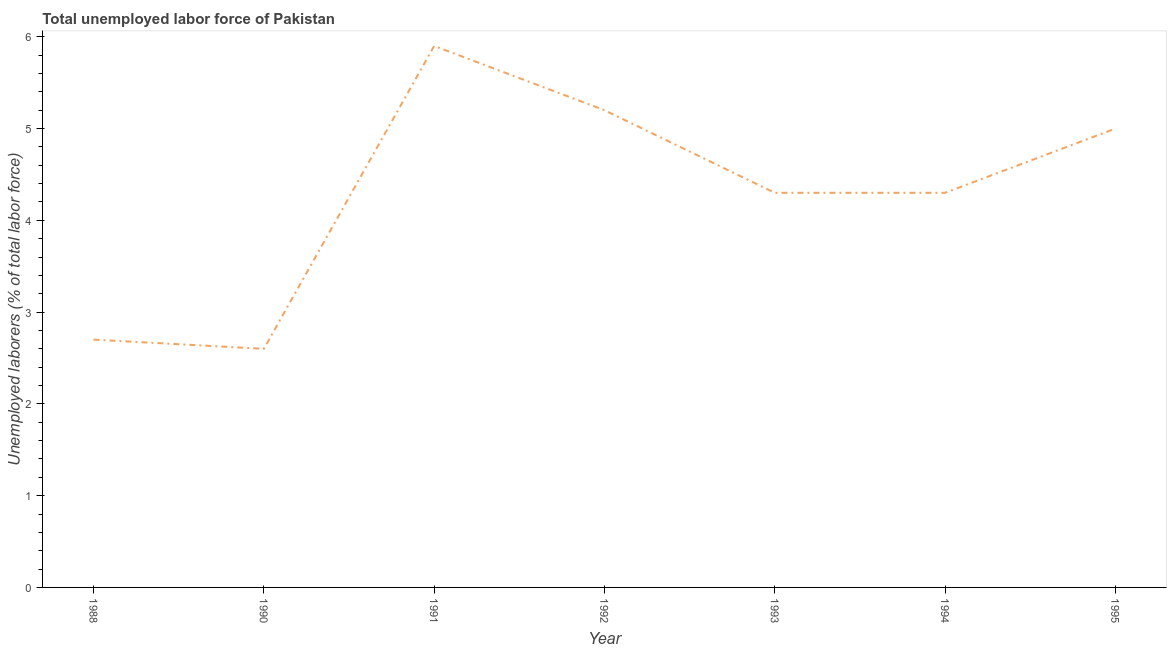What is the total unemployed labour force in 1992?
Give a very brief answer. 5.2. Across all years, what is the maximum total unemployed labour force?
Your answer should be very brief. 5.9. Across all years, what is the minimum total unemployed labour force?
Your response must be concise. 2.6. In which year was the total unemployed labour force maximum?
Your response must be concise. 1991. What is the sum of the total unemployed labour force?
Provide a short and direct response. 30. What is the difference between the total unemployed labour force in 1993 and 1995?
Provide a short and direct response. -0.7. What is the average total unemployed labour force per year?
Offer a terse response. 4.29. What is the median total unemployed labour force?
Ensure brevity in your answer.  4.3. Do a majority of the years between 1988 and 1991 (inclusive) have total unemployed labour force greater than 2.8 %?
Ensure brevity in your answer.  No. What is the ratio of the total unemployed labour force in 1993 to that in 1995?
Give a very brief answer. 0.86. Is the total unemployed labour force in 1988 less than that in 1993?
Offer a terse response. Yes. What is the difference between the highest and the second highest total unemployed labour force?
Your answer should be compact. 0.7. Is the sum of the total unemployed labour force in 1993 and 1994 greater than the maximum total unemployed labour force across all years?
Keep it short and to the point. Yes. What is the difference between the highest and the lowest total unemployed labour force?
Your response must be concise. 3.3. Does the total unemployed labour force monotonically increase over the years?
Give a very brief answer. No. How many years are there in the graph?
Make the answer very short. 7. Are the values on the major ticks of Y-axis written in scientific E-notation?
Keep it short and to the point. No. Does the graph contain grids?
Provide a short and direct response. No. What is the title of the graph?
Offer a very short reply. Total unemployed labor force of Pakistan. What is the label or title of the Y-axis?
Your answer should be compact. Unemployed laborers (% of total labor force). What is the Unemployed laborers (% of total labor force) in 1988?
Your answer should be very brief. 2.7. What is the Unemployed laborers (% of total labor force) of 1990?
Keep it short and to the point. 2.6. What is the Unemployed laborers (% of total labor force) in 1991?
Your answer should be compact. 5.9. What is the Unemployed laborers (% of total labor force) in 1992?
Provide a succinct answer. 5.2. What is the Unemployed laborers (% of total labor force) in 1993?
Offer a very short reply. 4.3. What is the Unemployed laborers (% of total labor force) in 1994?
Your answer should be compact. 4.3. What is the difference between the Unemployed laborers (% of total labor force) in 1988 and 1990?
Ensure brevity in your answer.  0.1. What is the difference between the Unemployed laborers (% of total labor force) in 1988 and 1991?
Provide a short and direct response. -3.2. What is the difference between the Unemployed laborers (% of total labor force) in 1988 and 1993?
Your answer should be very brief. -1.6. What is the difference between the Unemployed laborers (% of total labor force) in 1988 and 1994?
Give a very brief answer. -1.6. What is the difference between the Unemployed laborers (% of total labor force) in 1988 and 1995?
Make the answer very short. -2.3. What is the difference between the Unemployed laborers (% of total labor force) in 1990 and 1991?
Provide a succinct answer. -3.3. What is the difference between the Unemployed laborers (% of total labor force) in 1990 and 1993?
Your response must be concise. -1.7. What is the difference between the Unemployed laborers (% of total labor force) in 1990 and 1995?
Provide a short and direct response. -2.4. What is the difference between the Unemployed laborers (% of total labor force) in 1991 and 1992?
Provide a short and direct response. 0.7. What is the difference between the Unemployed laborers (% of total labor force) in 1992 and 1993?
Offer a terse response. 0.9. What is the difference between the Unemployed laborers (% of total labor force) in 1992 and 1994?
Your answer should be very brief. 0.9. What is the difference between the Unemployed laborers (% of total labor force) in 1992 and 1995?
Your answer should be very brief. 0.2. What is the difference between the Unemployed laborers (% of total labor force) in 1994 and 1995?
Your response must be concise. -0.7. What is the ratio of the Unemployed laborers (% of total labor force) in 1988 to that in 1990?
Offer a very short reply. 1.04. What is the ratio of the Unemployed laborers (% of total labor force) in 1988 to that in 1991?
Ensure brevity in your answer.  0.46. What is the ratio of the Unemployed laborers (% of total labor force) in 1988 to that in 1992?
Give a very brief answer. 0.52. What is the ratio of the Unemployed laborers (% of total labor force) in 1988 to that in 1993?
Make the answer very short. 0.63. What is the ratio of the Unemployed laborers (% of total labor force) in 1988 to that in 1994?
Give a very brief answer. 0.63. What is the ratio of the Unemployed laborers (% of total labor force) in 1988 to that in 1995?
Provide a succinct answer. 0.54. What is the ratio of the Unemployed laborers (% of total labor force) in 1990 to that in 1991?
Offer a terse response. 0.44. What is the ratio of the Unemployed laborers (% of total labor force) in 1990 to that in 1992?
Your response must be concise. 0.5. What is the ratio of the Unemployed laborers (% of total labor force) in 1990 to that in 1993?
Give a very brief answer. 0.6. What is the ratio of the Unemployed laborers (% of total labor force) in 1990 to that in 1994?
Make the answer very short. 0.6. What is the ratio of the Unemployed laborers (% of total labor force) in 1990 to that in 1995?
Your answer should be compact. 0.52. What is the ratio of the Unemployed laborers (% of total labor force) in 1991 to that in 1992?
Provide a short and direct response. 1.14. What is the ratio of the Unemployed laborers (% of total labor force) in 1991 to that in 1993?
Your answer should be very brief. 1.37. What is the ratio of the Unemployed laborers (% of total labor force) in 1991 to that in 1994?
Offer a very short reply. 1.37. What is the ratio of the Unemployed laborers (% of total labor force) in 1991 to that in 1995?
Make the answer very short. 1.18. What is the ratio of the Unemployed laborers (% of total labor force) in 1992 to that in 1993?
Give a very brief answer. 1.21. What is the ratio of the Unemployed laborers (% of total labor force) in 1992 to that in 1994?
Your answer should be very brief. 1.21. What is the ratio of the Unemployed laborers (% of total labor force) in 1993 to that in 1995?
Offer a terse response. 0.86. What is the ratio of the Unemployed laborers (% of total labor force) in 1994 to that in 1995?
Keep it short and to the point. 0.86. 